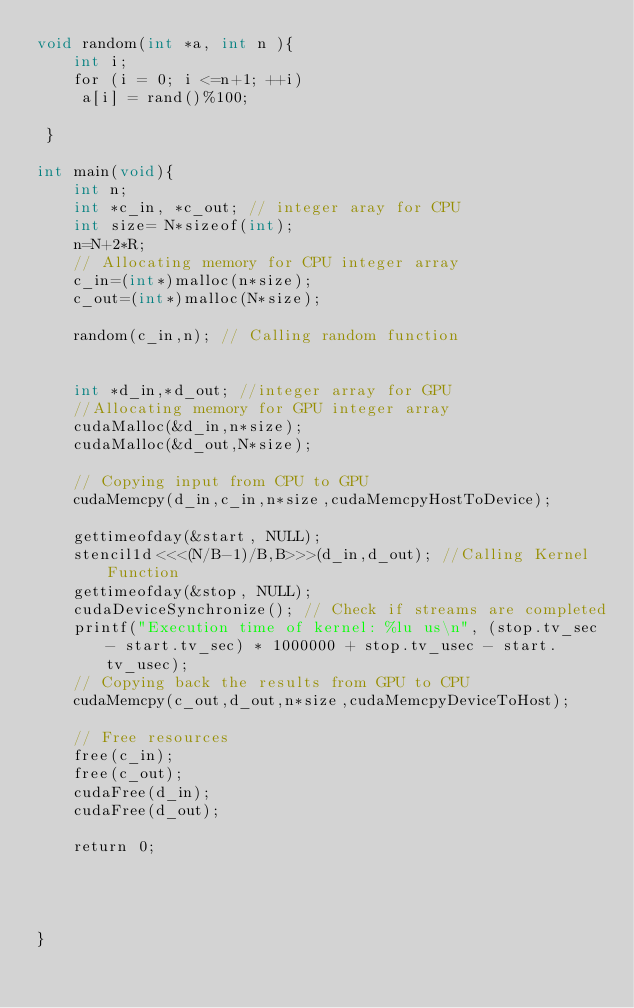Convert code to text. <code><loc_0><loc_0><loc_500><loc_500><_Cuda_>void random(int *a, int n ){
    int i;
    for (i = 0; i <=n+1; ++i)
     a[i] = rand()%100;
     
 }

int main(void){
    int n;
    int *c_in, *c_out; // integer aray for CPU
    int size= N*sizeof(int);
    n=N+2*R;
    // Allocating memory for CPU integer array 
    c_in=(int*)malloc(n*size);
    c_out=(int*)malloc(N*size);

    random(c_in,n); // Calling random function
    

    int *d_in,*d_out; //integer array for GPU
    //Allocating memory for GPU integer array
    cudaMalloc(&d_in,n*size);
    cudaMalloc(&d_out,N*size);

    // Copying input from CPU to GPU
    cudaMemcpy(d_in,c_in,n*size,cudaMemcpyHostToDevice);

    gettimeofday(&start, NULL);
    stencil1d<<<(N/B-1)/B,B>>>(d_in,d_out); //Calling Kernel Function
    gettimeofday(&stop, NULL);
    cudaDeviceSynchronize(); // Check if streams are completed
    printf("Execution time of kernel: %lu us\n", (stop.tv_sec - start.tv_sec) * 1000000 + stop.tv_usec - start.tv_usec);
    // Copying back the results from GPU to CPU
    cudaMemcpy(c_out,d_out,n*size,cudaMemcpyDeviceToHost);

    // Free resources
    free(c_in);
    free(c_out);
    cudaFree(d_in);
    cudaFree(d_out);

    return 0;




}</code> 